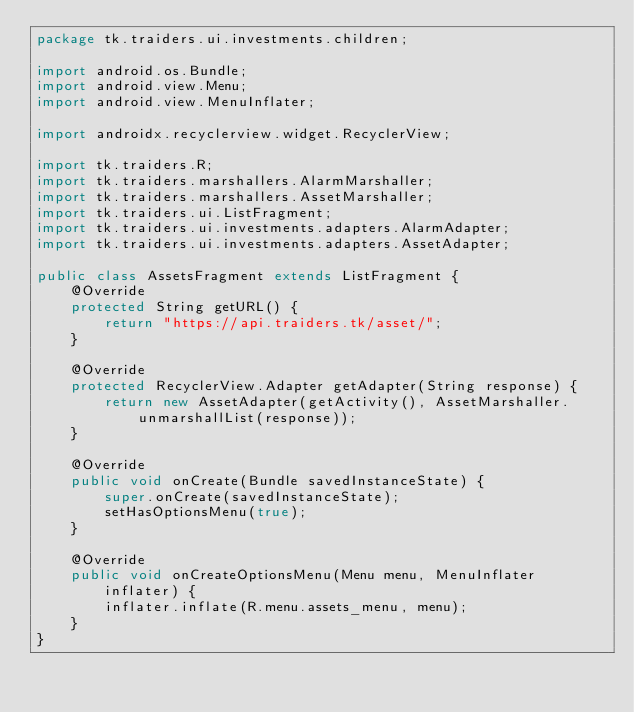Convert code to text. <code><loc_0><loc_0><loc_500><loc_500><_Java_>package tk.traiders.ui.investments.children;

import android.os.Bundle;
import android.view.Menu;
import android.view.MenuInflater;

import androidx.recyclerview.widget.RecyclerView;

import tk.traiders.R;
import tk.traiders.marshallers.AlarmMarshaller;
import tk.traiders.marshallers.AssetMarshaller;
import tk.traiders.ui.ListFragment;
import tk.traiders.ui.investments.adapters.AlarmAdapter;
import tk.traiders.ui.investments.adapters.AssetAdapter;

public class AssetsFragment extends ListFragment {
    @Override
    protected String getURL() {
        return "https://api.traiders.tk/asset/";
    }

    @Override
    protected RecyclerView.Adapter getAdapter(String response) {
        return new AssetAdapter(getActivity(), AssetMarshaller.unmarshallList(response));
    }

    @Override
    public void onCreate(Bundle savedInstanceState) {
        super.onCreate(savedInstanceState);
        setHasOptionsMenu(true);
    }

    @Override
    public void onCreateOptionsMenu(Menu menu, MenuInflater inflater) {
        inflater.inflate(R.menu.assets_menu, menu);
    }
}
</code> 